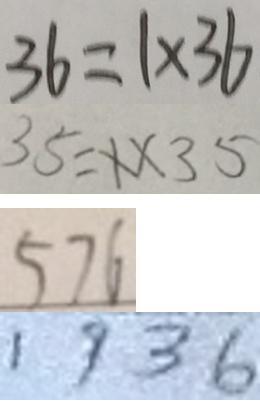Convert formula to latex. <formula><loc_0><loc_0><loc_500><loc_500>3 6 = 1 \times 3 6 
 3 5 = 1 \times 3 5 
 5 7 6 
 1 9 3 6</formula> 